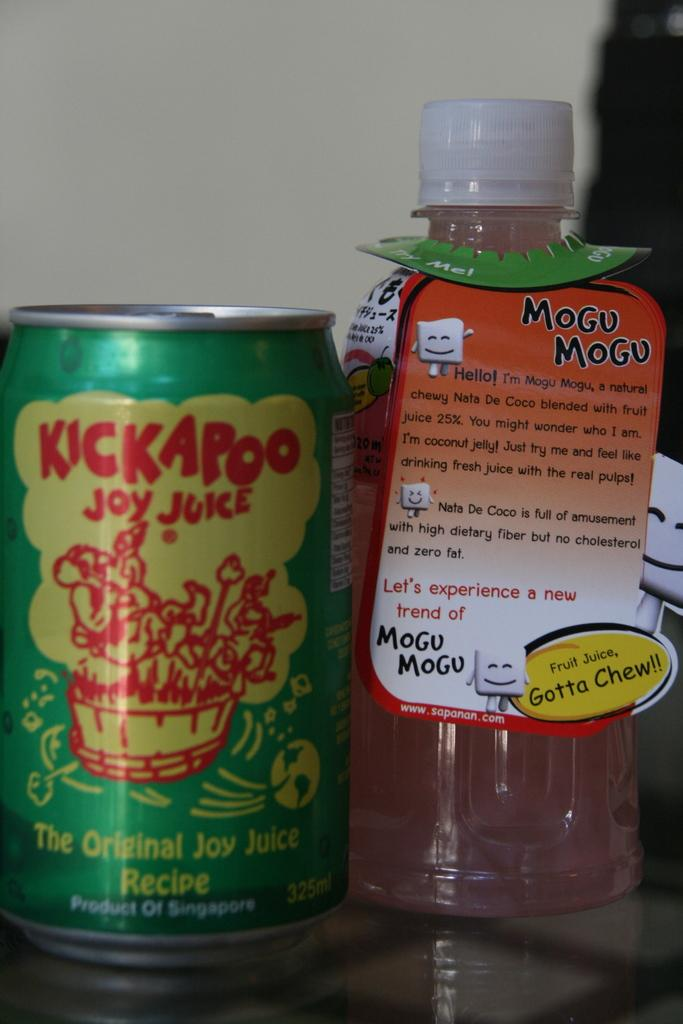Provide a one-sentence caption for the provided image. A bottle of Mogu Mogu and A can of KickAPoo sit next to each other on a table. 